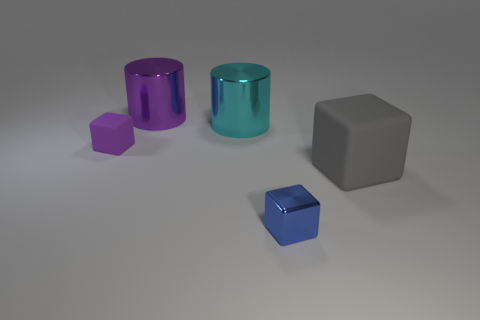Add 1 purple matte cubes. How many objects exist? 6 Subtract all cylinders. How many objects are left? 3 Subtract 1 gray blocks. How many objects are left? 4 Subtract all gray matte objects. Subtract all blue things. How many objects are left? 3 Add 1 big gray cubes. How many big gray cubes are left? 2 Add 1 big things. How many big things exist? 4 